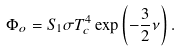<formula> <loc_0><loc_0><loc_500><loc_500>\Phi _ { o } = S _ { 1 } \sigma T _ { c } ^ { 4 } \exp \left ( - \frac { 3 } { 2 } \nu \right ) .</formula> 